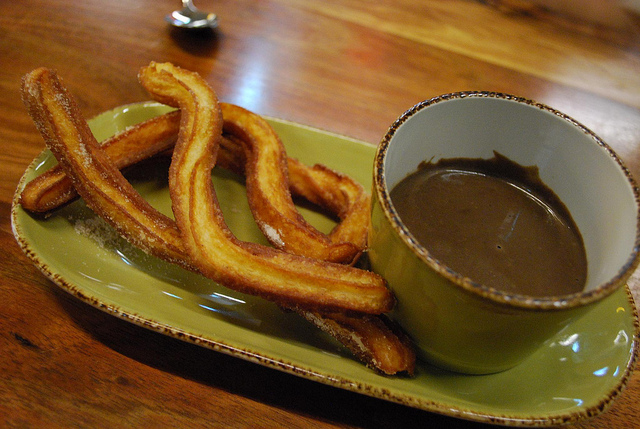How many containers are white? There are no white containers present in this scene. 